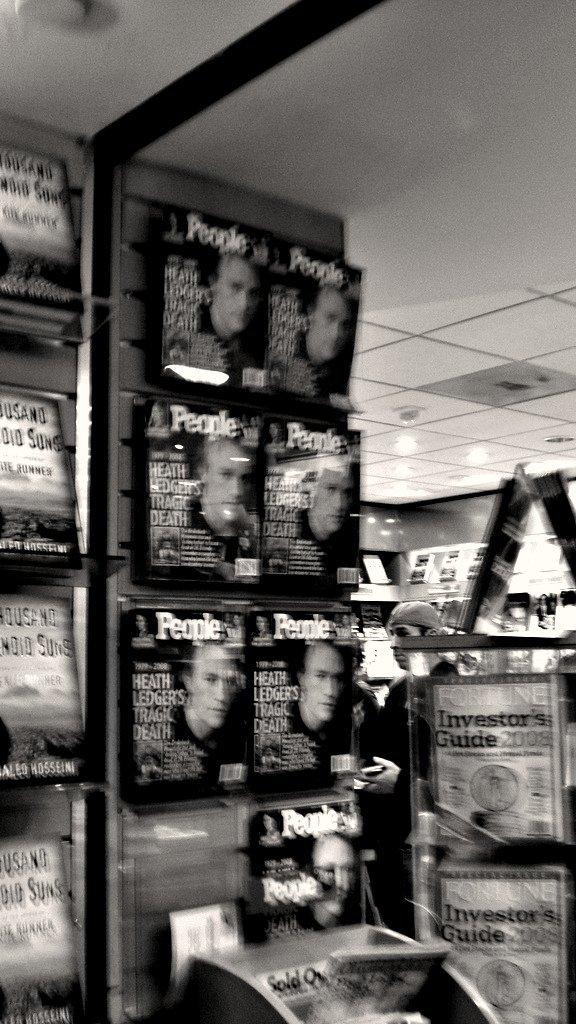What is the person in the image doing? There is a person standing inside the shop. What type of items can be found in the shop? There are many books in the shop. What is the color scheme of the image? The image is black and white. What type of base can be seen supporting the island in the image? There is no base or island present in the image; it features a person standing inside a shop with many books. 